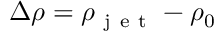<formula> <loc_0><loc_0><loc_500><loc_500>\Delta \rho = \rho _ { j e t } - \rho _ { 0 }</formula> 